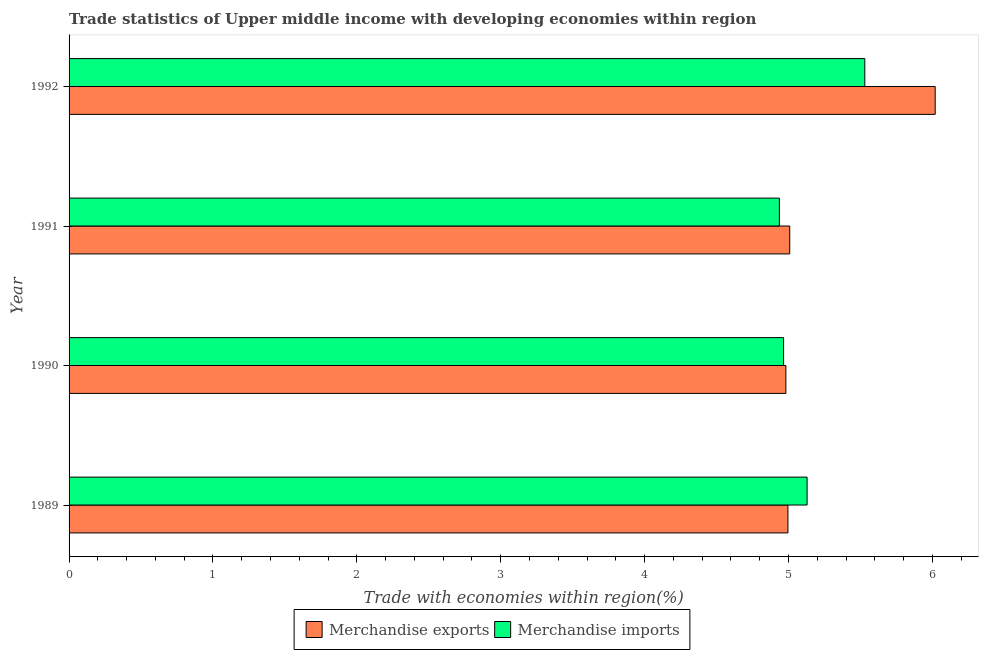How many groups of bars are there?
Your response must be concise. 4. Are the number of bars per tick equal to the number of legend labels?
Offer a terse response. Yes. In how many cases, is the number of bars for a given year not equal to the number of legend labels?
Provide a succinct answer. 0. What is the merchandise exports in 1989?
Offer a terse response. 5. Across all years, what is the maximum merchandise imports?
Keep it short and to the point. 5.53. Across all years, what is the minimum merchandise exports?
Your answer should be very brief. 4.98. In which year was the merchandise imports maximum?
Keep it short and to the point. 1992. What is the total merchandise exports in the graph?
Ensure brevity in your answer.  21.01. What is the difference between the merchandise imports in 1990 and that in 1992?
Offer a terse response. -0.56. What is the difference between the merchandise exports in 1989 and the merchandise imports in 1991?
Ensure brevity in your answer.  0.06. What is the average merchandise imports per year?
Your answer should be very brief. 5.14. In the year 1989, what is the difference between the merchandise imports and merchandise exports?
Offer a terse response. 0.13. In how many years, is the merchandise imports greater than 0.2 %?
Your answer should be very brief. 4. What is the ratio of the merchandise imports in 1991 to that in 1992?
Your answer should be very brief. 0.89. Is the merchandise imports in 1990 less than that in 1992?
Provide a short and direct response. Yes. What is the difference between the highest and the second highest merchandise imports?
Your answer should be compact. 0.4. Is the sum of the merchandise imports in 1989 and 1992 greater than the maximum merchandise exports across all years?
Provide a short and direct response. Yes. How many bars are there?
Provide a short and direct response. 8. Are all the bars in the graph horizontal?
Your response must be concise. Yes. What is the difference between two consecutive major ticks on the X-axis?
Keep it short and to the point. 1. Does the graph contain any zero values?
Your answer should be compact. No. What is the title of the graph?
Your answer should be very brief. Trade statistics of Upper middle income with developing economies within region. What is the label or title of the X-axis?
Give a very brief answer. Trade with economies within region(%). What is the label or title of the Y-axis?
Provide a succinct answer. Year. What is the Trade with economies within region(%) in Merchandise exports in 1989?
Keep it short and to the point. 5. What is the Trade with economies within region(%) in Merchandise imports in 1989?
Ensure brevity in your answer.  5.13. What is the Trade with economies within region(%) of Merchandise exports in 1990?
Make the answer very short. 4.98. What is the Trade with economies within region(%) of Merchandise imports in 1990?
Offer a very short reply. 4.97. What is the Trade with economies within region(%) in Merchandise exports in 1991?
Give a very brief answer. 5.01. What is the Trade with economies within region(%) in Merchandise imports in 1991?
Your answer should be compact. 4.94. What is the Trade with economies within region(%) of Merchandise exports in 1992?
Ensure brevity in your answer.  6.02. What is the Trade with economies within region(%) of Merchandise imports in 1992?
Provide a succinct answer. 5.53. Across all years, what is the maximum Trade with economies within region(%) of Merchandise exports?
Offer a very short reply. 6.02. Across all years, what is the maximum Trade with economies within region(%) in Merchandise imports?
Give a very brief answer. 5.53. Across all years, what is the minimum Trade with economies within region(%) of Merchandise exports?
Offer a terse response. 4.98. Across all years, what is the minimum Trade with economies within region(%) in Merchandise imports?
Give a very brief answer. 4.94. What is the total Trade with economies within region(%) of Merchandise exports in the graph?
Provide a succinct answer. 21.01. What is the total Trade with economies within region(%) of Merchandise imports in the graph?
Your answer should be compact. 20.56. What is the difference between the Trade with economies within region(%) of Merchandise exports in 1989 and that in 1990?
Ensure brevity in your answer.  0.01. What is the difference between the Trade with economies within region(%) in Merchandise imports in 1989 and that in 1990?
Offer a very short reply. 0.16. What is the difference between the Trade with economies within region(%) of Merchandise exports in 1989 and that in 1991?
Provide a short and direct response. -0.01. What is the difference between the Trade with economies within region(%) of Merchandise imports in 1989 and that in 1991?
Offer a terse response. 0.19. What is the difference between the Trade with economies within region(%) of Merchandise exports in 1989 and that in 1992?
Provide a short and direct response. -1.02. What is the difference between the Trade with economies within region(%) in Merchandise imports in 1989 and that in 1992?
Keep it short and to the point. -0.4. What is the difference between the Trade with economies within region(%) in Merchandise exports in 1990 and that in 1991?
Offer a very short reply. -0.03. What is the difference between the Trade with economies within region(%) in Merchandise imports in 1990 and that in 1991?
Offer a very short reply. 0.03. What is the difference between the Trade with economies within region(%) of Merchandise exports in 1990 and that in 1992?
Keep it short and to the point. -1.04. What is the difference between the Trade with economies within region(%) of Merchandise imports in 1990 and that in 1992?
Your answer should be very brief. -0.56. What is the difference between the Trade with economies within region(%) in Merchandise exports in 1991 and that in 1992?
Offer a very short reply. -1.01. What is the difference between the Trade with economies within region(%) of Merchandise imports in 1991 and that in 1992?
Ensure brevity in your answer.  -0.59. What is the difference between the Trade with economies within region(%) in Merchandise exports in 1989 and the Trade with economies within region(%) in Merchandise imports in 1990?
Make the answer very short. 0.03. What is the difference between the Trade with economies within region(%) in Merchandise exports in 1989 and the Trade with economies within region(%) in Merchandise imports in 1991?
Provide a succinct answer. 0.06. What is the difference between the Trade with economies within region(%) in Merchandise exports in 1989 and the Trade with economies within region(%) in Merchandise imports in 1992?
Make the answer very short. -0.53. What is the difference between the Trade with economies within region(%) of Merchandise exports in 1990 and the Trade with economies within region(%) of Merchandise imports in 1991?
Provide a succinct answer. 0.05. What is the difference between the Trade with economies within region(%) in Merchandise exports in 1990 and the Trade with economies within region(%) in Merchandise imports in 1992?
Offer a terse response. -0.55. What is the difference between the Trade with economies within region(%) of Merchandise exports in 1991 and the Trade with economies within region(%) of Merchandise imports in 1992?
Keep it short and to the point. -0.52. What is the average Trade with economies within region(%) of Merchandise exports per year?
Offer a very short reply. 5.25. What is the average Trade with economies within region(%) in Merchandise imports per year?
Offer a very short reply. 5.14. In the year 1989, what is the difference between the Trade with economies within region(%) of Merchandise exports and Trade with economies within region(%) of Merchandise imports?
Your response must be concise. -0.13. In the year 1990, what is the difference between the Trade with economies within region(%) of Merchandise exports and Trade with economies within region(%) of Merchandise imports?
Your answer should be compact. 0.02. In the year 1991, what is the difference between the Trade with economies within region(%) of Merchandise exports and Trade with economies within region(%) of Merchandise imports?
Provide a short and direct response. 0.07. In the year 1992, what is the difference between the Trade with economies within region(%) of Merchandise exports and Trade with economies within region(%) of Merchandise imports?
Ensure brevity in your answer.  0.49. What is the ratio of the Trade with economies within region(%) in Merchandise exports in 1989 to that in 1990?
Provide a short and direct response. 1. What is the ratio of the Trade with economies within region(%) of Merchandise imports in 1989 to that in 1990?
Your answer should be compact. 1.03. What is the ratio of the Trade with economies within region(%) in Merchandise exports in 1989 to that in 1991?
Offer a very short reply. 1. What is the ratio of the Trade with economies within region(%) in Merchandise imports in 1989 to that in 1991?
Your response must be concise. 1.04. What is the ratio of the Trade with economies within region(%) of Merchandise exports in 1989 to that in 1992?
Your answer should be compact. 0.83. What is the ratio of the Trade with economies within region(%) of Merchandise imports in 1989 to that in 1992?
Provide a succinct answer. 0.93. What is the ratio of the Trade with economies within region(%) of Merchandise imports in 1990 to that in 1991?
Offer a very short reply. 1.01. What is the ratio of the Trade with economies within region(%) in Merchandise exports in 1990 to that in 1992?
Offer a terse response. 0.83. What is the ratio of the Trade with economies within region(%) of Merchandise imports in 1990 to that in 1992?
Your answer should be very brief. 0.9. What is the ratio of the Trade with economies within region(%) in Merchandise exports in 1991 to that in 1992?
Keep it short and to the point. 0.83. What is the ratio of the Trade with economies within region(%) in Merchandise imports in 1991 to that in 1992?
Offer a terse response. 0.89. What is the difference between the highest and the second highest Trade with economies within region(%) of Merchandise exports?
Keep it short and to the point. 1.01. What is the difference between the highest and the second highest Trade with economies within region(%) of Merchandise imports?
Offer a very short reply. 0.4. What is the difference between the highest and the lowest Trade with economies within region(%) in Merchandise exports?
Keep it short and to the point. 1.04. What is the difference between the highest and the lowest Trade with economies within region(%) of Merchandise imports?
Keep it short and to the point. 0.59. 